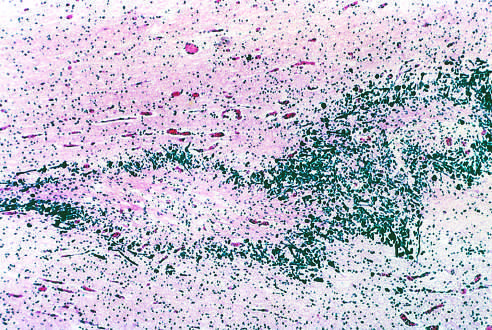does nonfunctioning adenomas contain a central focus of white matter necrosis with a peripheral rim of mineralized axonal processes?
Answer the question using a single word or phrase. No 